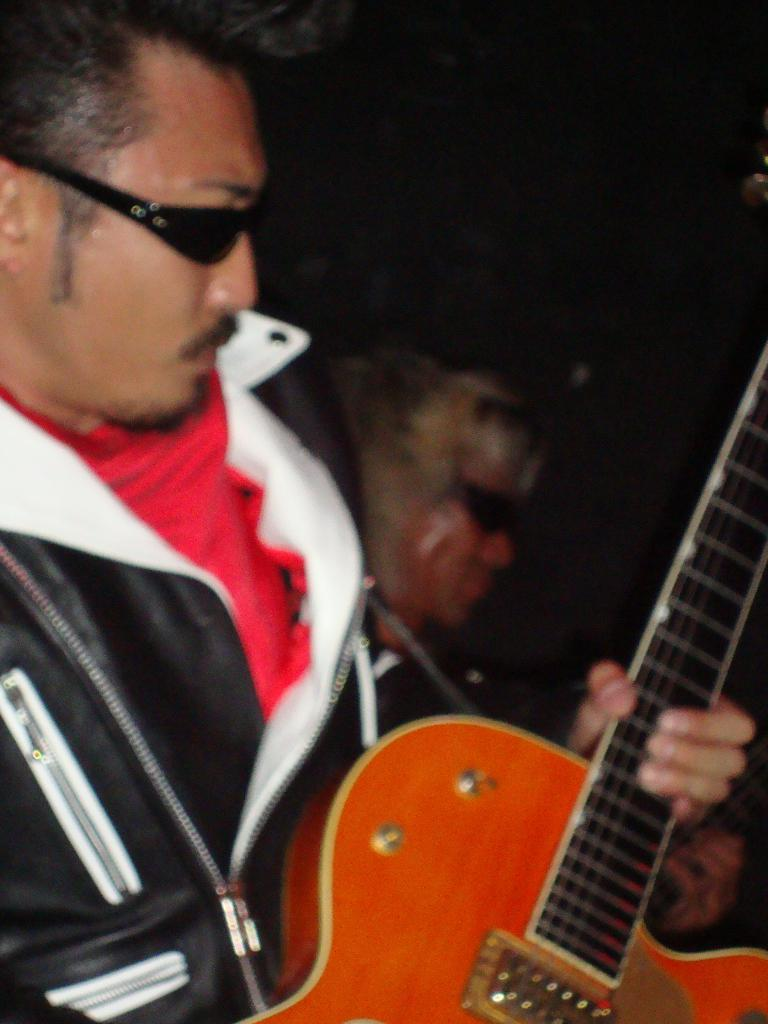What is the man in the image doing? The man in the image is playing a guitar. Can you describe the activity of the man in the image? The man is playing a guitar, which suggests he might be a musician or performing for an audience. Is there anyone else visible in the image? Yes, there is another person in the background of the image. What color is the orange that the man is holding in the image? There is no orange present in the image; the man is playing a guitar. How many knees can be seen in the image? There is no specific mention of knees in the image, so it is not possible to determine the number of knees visible. 